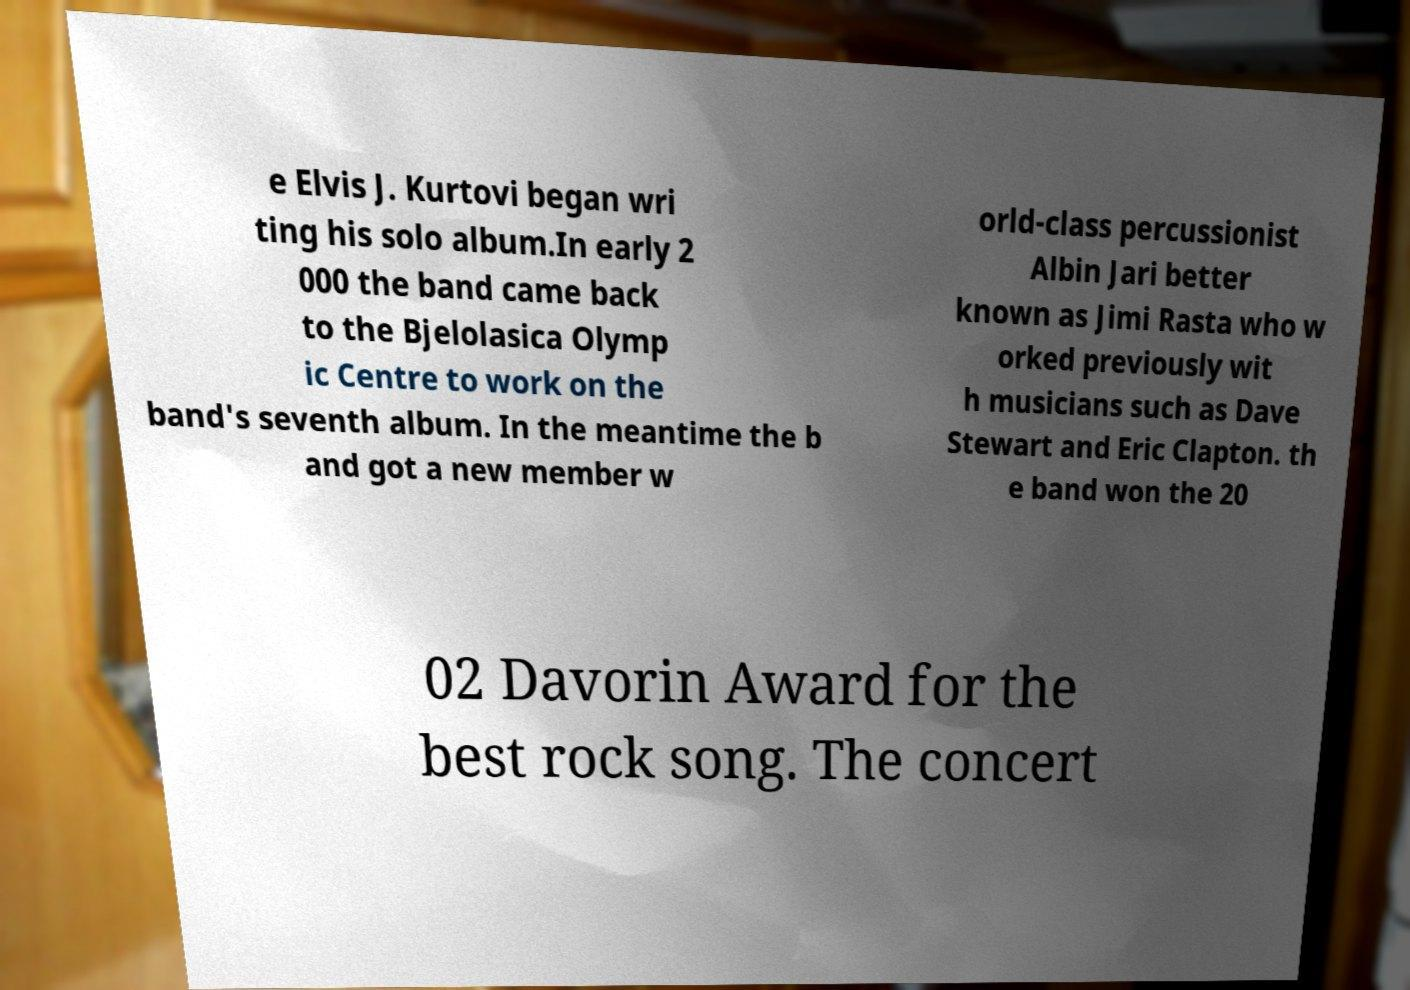There's text embedded in this image that I need extracted. Can you transcribe it verbatim? e Elvis J. Kurtovi began wri ting his solo album.In early 2 000 the band came back to the Bjelolasica Olymp ic Centre to work on the band's seventh album. In the meantime the b and got a new member w orld-class percussionist Albin Jari better known as Jimi Rasta who w orked previously wit h musicians such as Dave Stewart and Eric Clapton. th e band won the 20 02 Davorin Award for the best rock song. The concert 